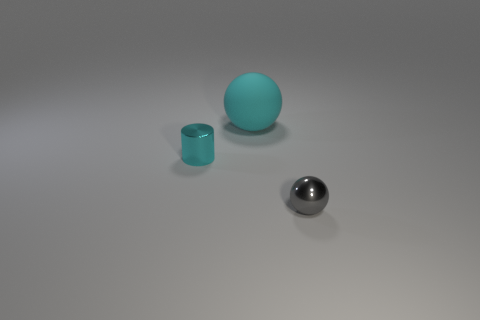Add 2 small cylinders. How many objects exist? 5 Subtract all cylinders. How many objects are left? 2 Add 2 large red rubber spheres. How many large red rubber spheres exist? 2 Subtract 0 blue spheres. How many objects are left? 3 Subtract all red cylinders. Subtract all shiny objects. How many objects are left? 1 Add 2 large objects. How many large objects are left? 3 